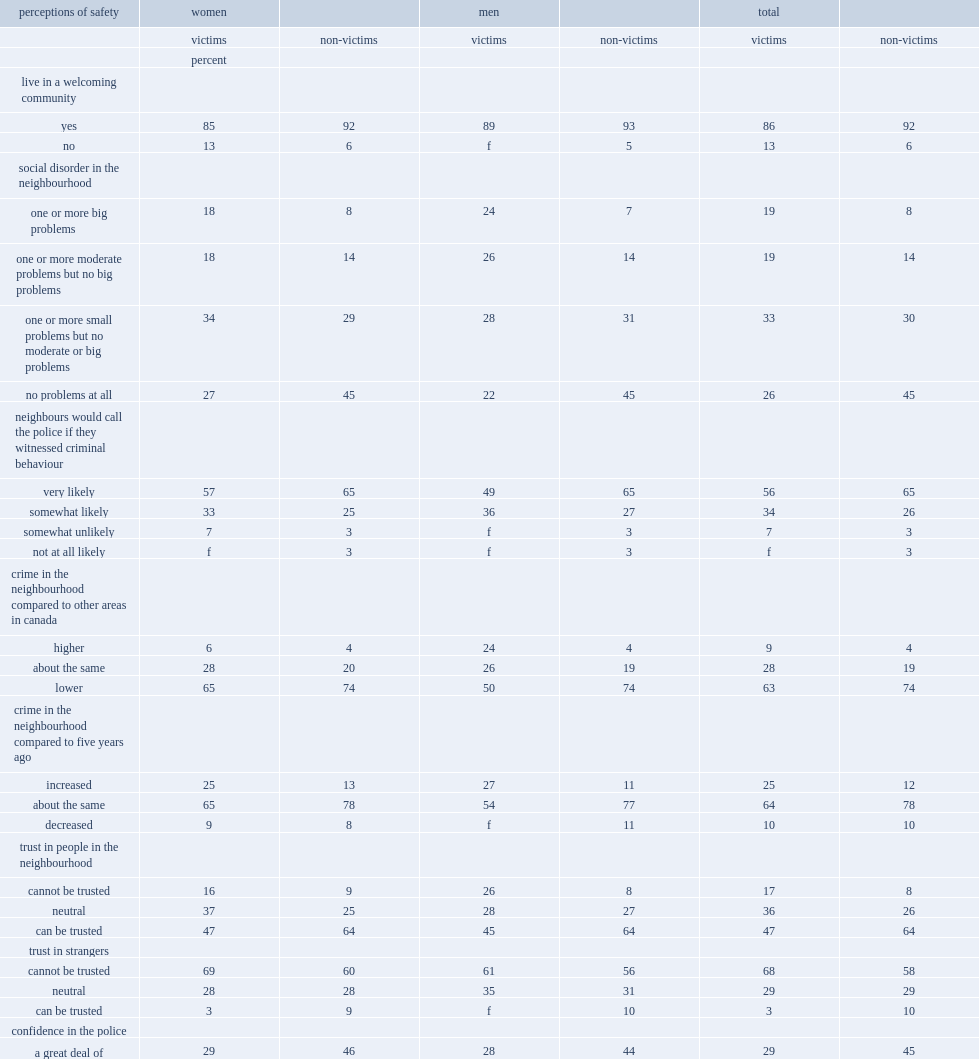What is the percentage of victims of sexual assault lived in a welcoming community? 86.0. What is the percentage of non-victims of sexual assault lived in a welcoming community? 92.0. Considering whether experiencd sexual assault,which kind of people were less likely to report that they lived in a welcoming community? Victims. Considering whether experiencd sexual assault,which kind of people were more likely to report that there were one or more big problems related to social disorder in their neighbourhood?victims or non-victims? Victims. Considering whether experiencd sexual assault,which kind of people were less likely to report that their neighbours were 'very likely' to call police if they witnessed criminal behaviour?victims or non-victims? Victims. What was the times victims were more likely to report that crime in their neighbourhood was higher than in other areas of canada compared to non-victims? 2.25. What was the times victims were more likely to report that crime had increased in their neighbourhood in the five years that preceded the survey compared to non-victims? 2.083333. Considering whether experiencd sexual assault,which kind of people were less likely to believe that strangers can be trusted ?victims or non-victims? Victims. Considering whether experiencd sexual assault,which kind of people were more likely to believe that neighbourhood can not be trusted ?victims or non-victims? Victims. Considering whether experiencd sexual assault,which kind of people were less likely to believe that strangers can be trusted ?victims or non-victims? Victims. Considering whether experiencd sexual assault,which kind of people were less likely to have 'a great deal of confidence' in the police? Victims. Considering whether experiencd sexual assault,which kind of people were more likely to have 'no confidence at all' in the police? Victims. 